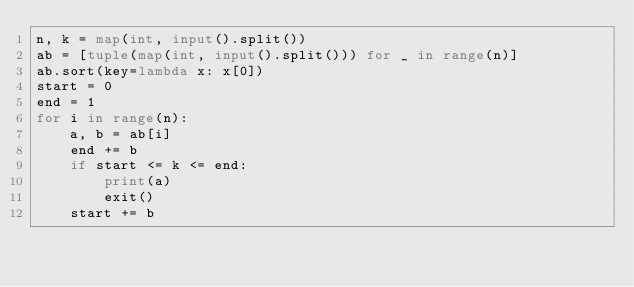Convert code to text. <code><loc_0><loc_0><loc_500><loc_500><_Python_>n, k = map(int, input().split())
ab = [tuple(map(int, input().split())) for _ in range(n)]
ab.sort(key=lambda x: x[0])
start = 0
end = 1
for i in range(n):
    a, b = ab[i]
    end += b
    if start <= k <= end:
        print(a)
        exit()
    start += b
</code> 